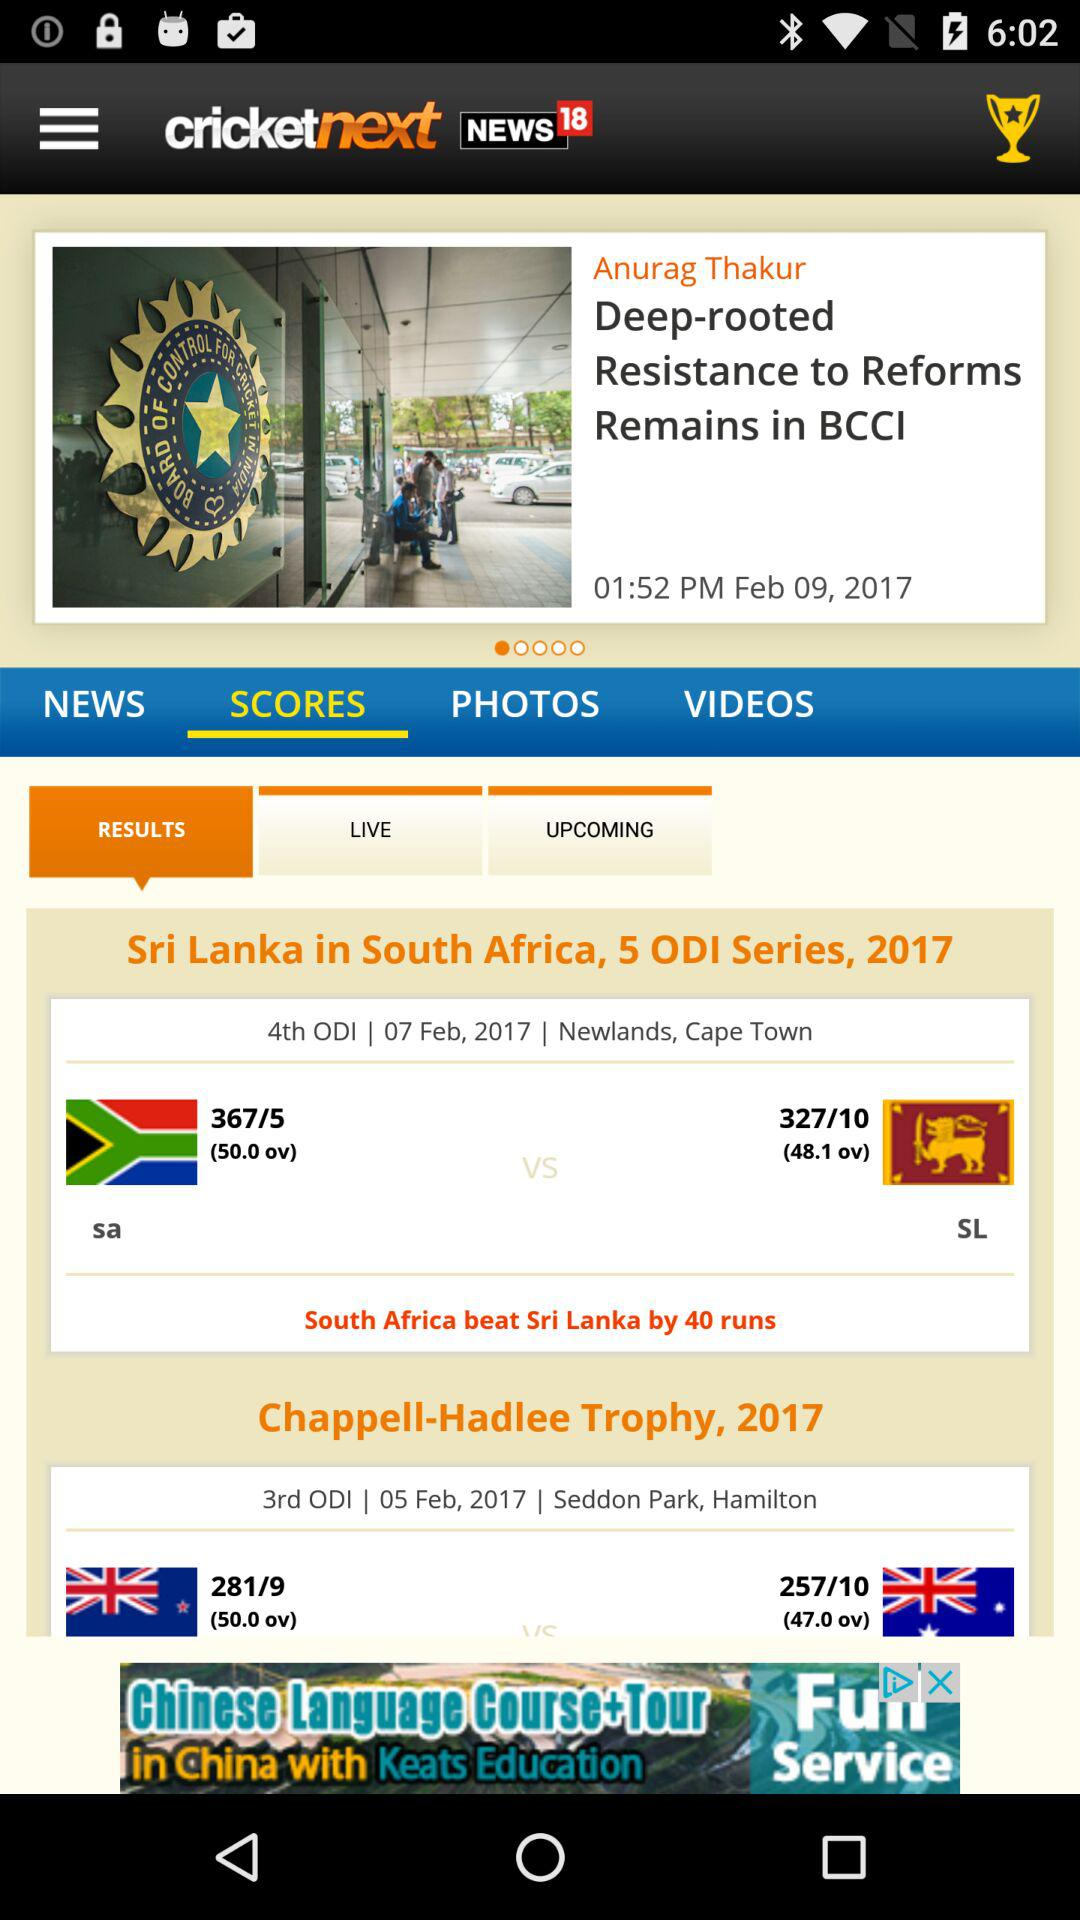At which venue was the "Sri Lanka" vs. "South Africa" match played? The match was played at Newlands, Cape Town. 